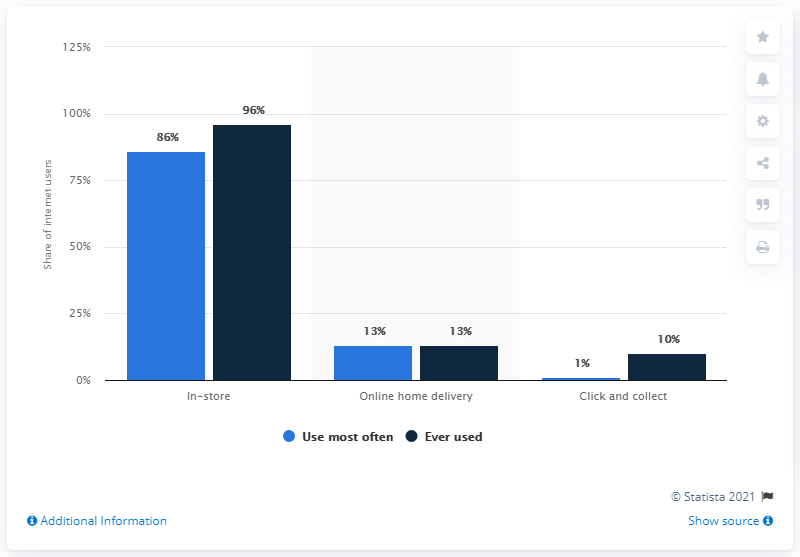Give some essential details in this illustration. According to a recent survey, a significant percentage of internet users prefer to use online home delivery services for their daily needs. The method that has the same value for the light blue and navy blue bars is online home delivery. 